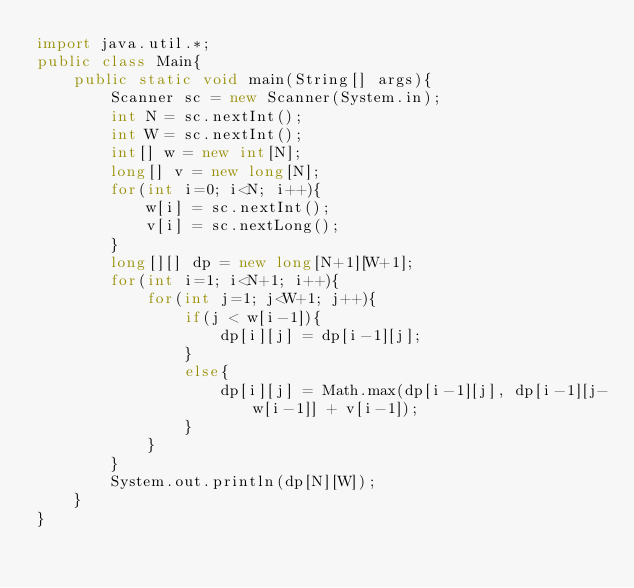<code> <loc_0><loc_0><loc_500><loc_500><_Java_>import java.util.*;
public class Main{
	public static void main(String[] args){
		Scanner sc = new Scanner(System.in);
		int N = sc.nextInt();
		int W = sc.nextInt();
		int[] w = new int[N];
		long[] v = new long[N];
		for(int i=0; i<N; i++){
			w[i] = sc.nextInt();
			v[i] = sc.nextLong();
		}
		long[][] dp = new long[N+1][W+1];
		for(int i=1; i<N+1; i++){
			for(int j=1; j<W+1; j++){
				if(j < w[i-1]){
					dp[i][j] = dp[i-1][j];
				}
				else{
					dp[i][j] = Math.max(dp[i-1][j], dp[i-1][j-w[i-1]] + v[i-1]);
				}
			}
		}
		System.out.println(dp[N][W]);
	}
}</code> 